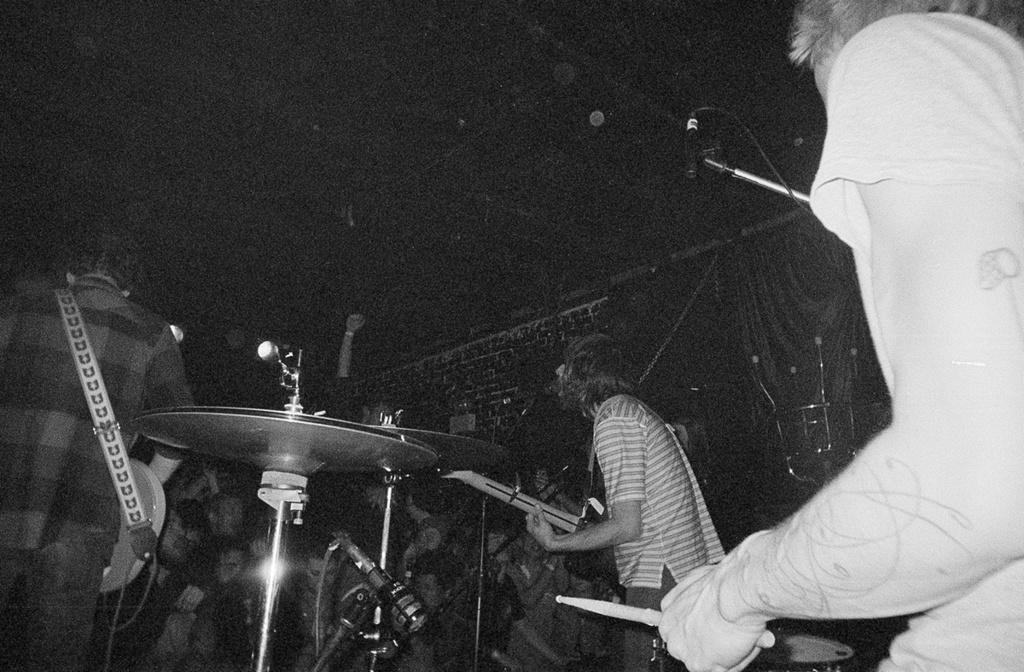What is happening in the image? There are people in the image, and they are playing musical instruments. Can you describe the actions of the people in the image? The people are playing musical instruments, which suggests they are performing or practicing music. What type of mask is being worn by the person playing the violin in the image? There is no person wearing a mask in the image, nor is there a person playing a violin. 